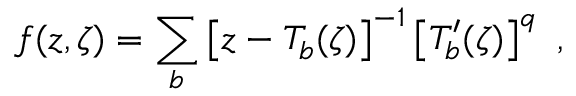<formula> <loc_0><loc_0><loc_500><loc_500>f ( z , \zeta ) = \sum _ { b } \left [ z - T _ { b } ( \zeta ) \right ] ^ { - 1 } \left [ T _ { b } ^ { \prime } ( \zeta ) \right ] ^ { q } \ ,</formula> 